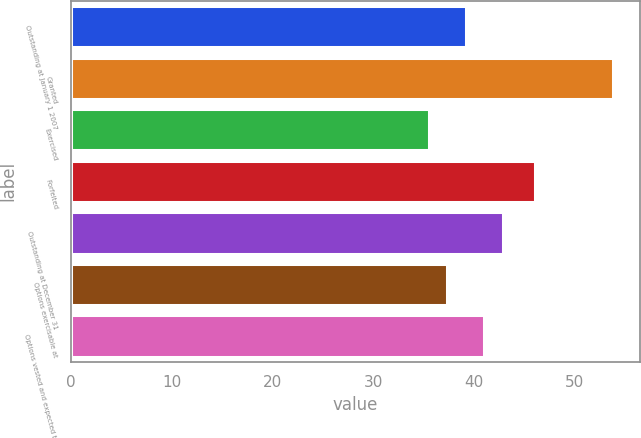<chart> <loc_0><loc_0><loc_500><loc_500><bar_chart><fcel>Outstanding at January 1 2007<fcel>Granted<fcel>Exercised<fcel>Forfeited<fcel>Outstanding at December 31<fcel>Options exercisable at<fcel>Options vested and expected to<nl><fcel>39.22<fcel>53.83<fcel>35.56<fcel>46.09<fcel>42.88<fcel>37.39<fcel>41.05<nl></chart> 